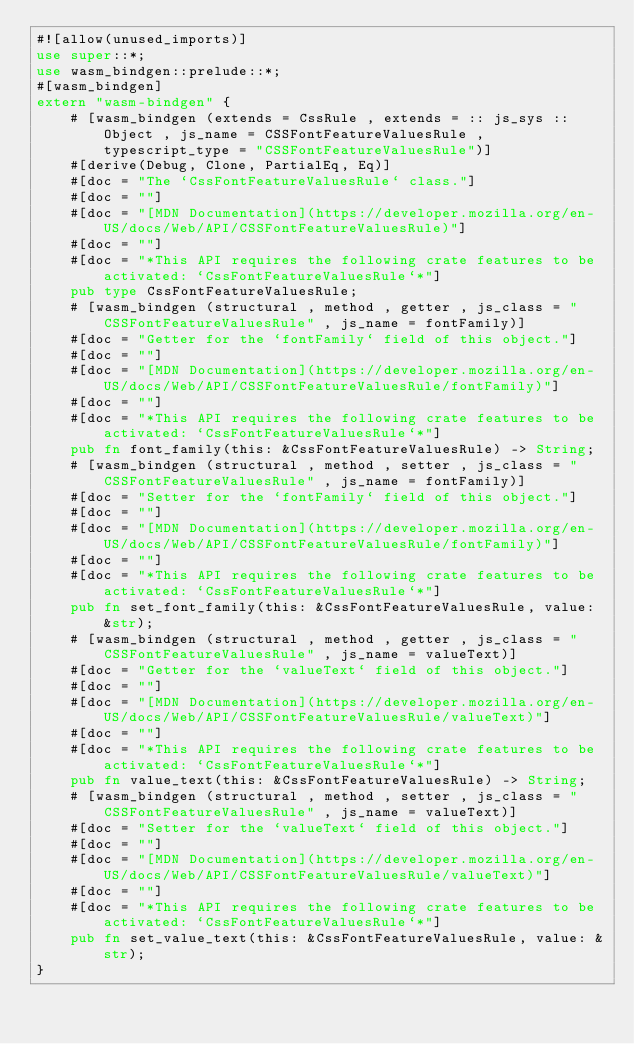Convert code to text. <code><loc_0><loc_0><loc_500><loc_500><_Rust_>#![allow(unused_imports)]
use super::*;
use wasm_bindgen::prelude::*;
#[wasm_bindgen]
extern "wasm-bindgen" {
    # [wasm_bindgen (extends = CssRule , extends = :: js_sys :: Object , js_name = CSSFontFeatureValuesRule , typescript_type = "CSSFontFeatureValuesRule")]
    #[derive(Debug, Clone, PartialEq, Eq)]
    #[doc = "The `CssFontFeatureValuesRule` class."]
    #[doc = ""]
    #[doc = "[MDN Documentation](https://developer.mozilla.org/en-US/docs/Web/API/CSSFontFeatureValuesRule)"]
    #[doc = ""]
    #[doc = "*This API requires the following crate features to be activated: `CssFontFeatureValuesRule`*"]
    pub type CssFontFeatureValuesRule;
    # [wasm_bindgen (structural , method , getter , js_class = "CSSFontFeatureValuesRule" , js_name = fontFamily)]
    #[doc = "Getter for the `fontFamily` field of this object."]
    #[doc = ""]
    #[doc = "[MDN Documentation](https://developer.mozilla.org/en-US/docs/Web/API/CSSFontFeatureValuesRule/fontFamily)"]
    #[doc = ""]
    #[doc = "*This API requires the following crate features to be activated: `CssFontFeatureValuesRule`*"]
    pub fn font_family(this: &CssFontFeatureValuesRule) -> String;
    # [wasm_bindgen (structural , method , setter , js_class = "CSSFontFeatureValuesRule" , js_name = fontFamily)]
    #[doc = "Setter for the `fontFamily` field of this object."]
    #[doc = ""]
    #[doc = "[MDN Documentation](https://developer.mozilla.org/en-US/docs/Web/API/CSSFontFeatureValuesRule/fontFamily)"]
    #[doc = ""]
    #[doc = "*This API requires the following crate features to be activated: `CssFontFeatureValuesRule`*"]
    pub fn set_font_family(this: &CssFontFeatureValuesRule, value: &str);
    # [wasm_bindgen (structural , method , getter , js_class = "CSSFontFeatureValuesRule" , js_name = valueText)]
    #[doc = "Getter for the `valueText` field of this object."]
    #[doc = ""]
    #[doc = "[MDN Documentation](https://developer.mozilla.org/en-US/docs/Web/API/CSSFontFeatureValuesRule/valueText)"]
    #[doc = ""]
    #[doc = "*This API requires the following crate features to be activated: `CssFontFeatureValuesRule`*"]
    pub fn value_text(this: &CssFontFeatureValuesRule) -> String;
    # [wasm_bindgen (structural , method , setter , js_class = "CSSFontFeatureValuesRule" , js_name = valueText)]
    #[doc = "Setter for the `valueText` field of this object."]
    #[doc = ""]
    #[doc = "[MDN Documentation](https://developer.mozilla.org/en-US/docs/Web/API/CSSFontFeatureValuesRule/valueText)"]
    #[doc = ""]
    #[doc = "*This API requires the following crate features to be activated: `CssFontFeatureValuesRule`*"]
    pub fn set_value_text(this: &CssFontFeatureValuesRule, value: &str);
}
</code> 